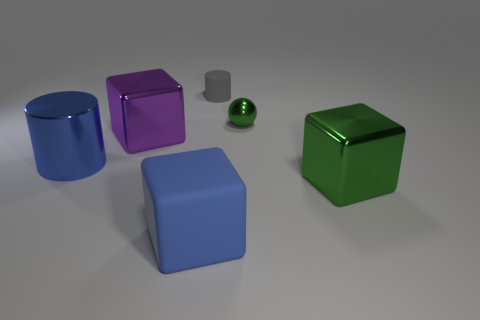Add 2 big blocks. How many objects exist? 8 Subtract all green cubes. How many cubes are left? 2 Subtract all spheres. How many objects are left? 5 Subtract all large green shiny cubes. Subtract all purple objects. How many objects are left? 4 Add 5 big rubber things. How many big rubber things are left? 6 Add 3 cubes. How many cubes exist? 6 Subtract 0 brown cylinders. How many objects are left? 6 Subtract all gray blocks. Subtract all brown spheres. How many blocks are left? 3 